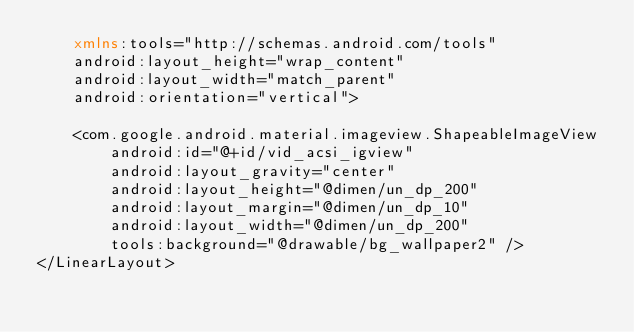<code> <loc_0><loc_0><loc_500><loc_500><_XML_>    xmlns:tools="http://schemas.android.com/tools"
    android:layout_height="wrap_content"
    android:layout_width="match_parent"
    android:orientation="vertical">

    <com.google.android.material.imageview.ShapeableImageView
        android:id="@+id/vid_acsi_igview"
        android:layout_gravity="center"
        android:layout_height="@dimen/un_dp_200"
        android:layout_margin="@dimen/un_dp_10"
        android:layout_width="@dimen/un_dp_200"
        tools:background="@drawable/bg_wallpaper2" />
</LinearLayout></code> 